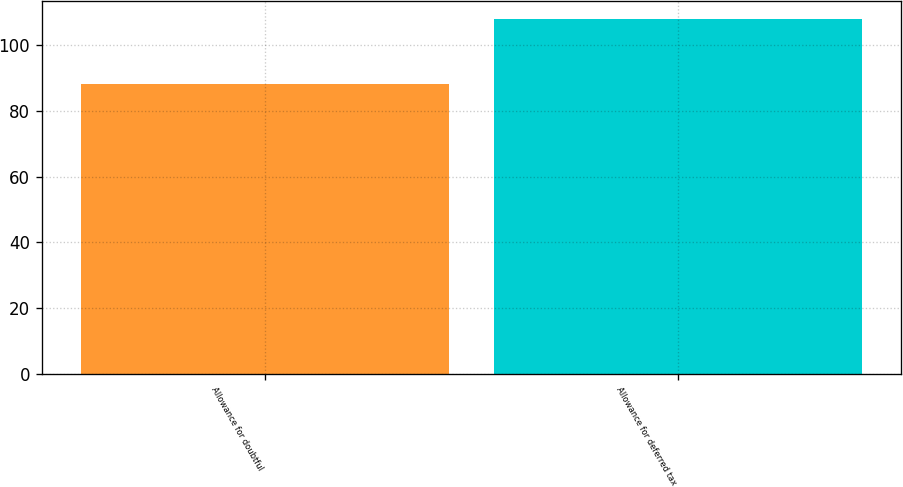<chart> <loc_0><loc_0><loc_500><loc_500><bar_chart><fcel>Allowance for doubtful<fcel>Allowance for deferred tax<nl><fcel>88<fcel>108<nl></chart> 